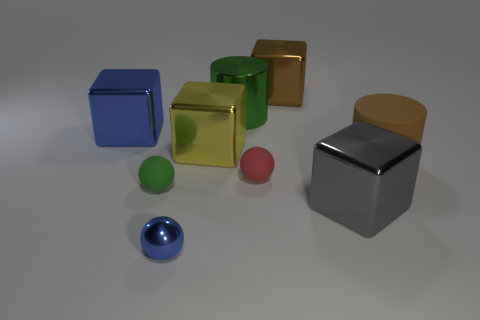There is a brown thing that is left of the large brown cylinder that is in front of the yellow metallic thing; what is its size?
Ensure brevity in your answer.  Large. There is another tiny matte object that is the same shape as the small red thing; what is its color?
Your answer should be compact. Green. Does the brown cube have the same size as the blue block?
Your answer should be compact. Yes. Are there an equal number of brown cylinders that are on the left side of the large brown matte thing and small brown shiny blocks?
Make the answer very short. Yes. Are there any green rubber spheres that are in front of the blue thing in front of the large yellow cube?
Give a very brief answer. No. What is the size of the metal cube that is in front of the large brown thing that is on the right side of the brown thing behind the big green cylinder?
Offer a terse response. Large. There is a cylinder in front of the blue metallic thing behind the yellow shiny cube; what is its material?
Keep it short and to the point. Rubber. Are there any tiny gray objects of the same shape as the green matte object?
Keep it short and to the point. No. What is the shape of the tiny blue metallic object?
Your answer should be compact. Sphere. What material is the cylinder right of the gray metallic cube in front of the tiny rubber object that is left of the tiny red ball?
Ensure brevity in your answer.  Rubber. 